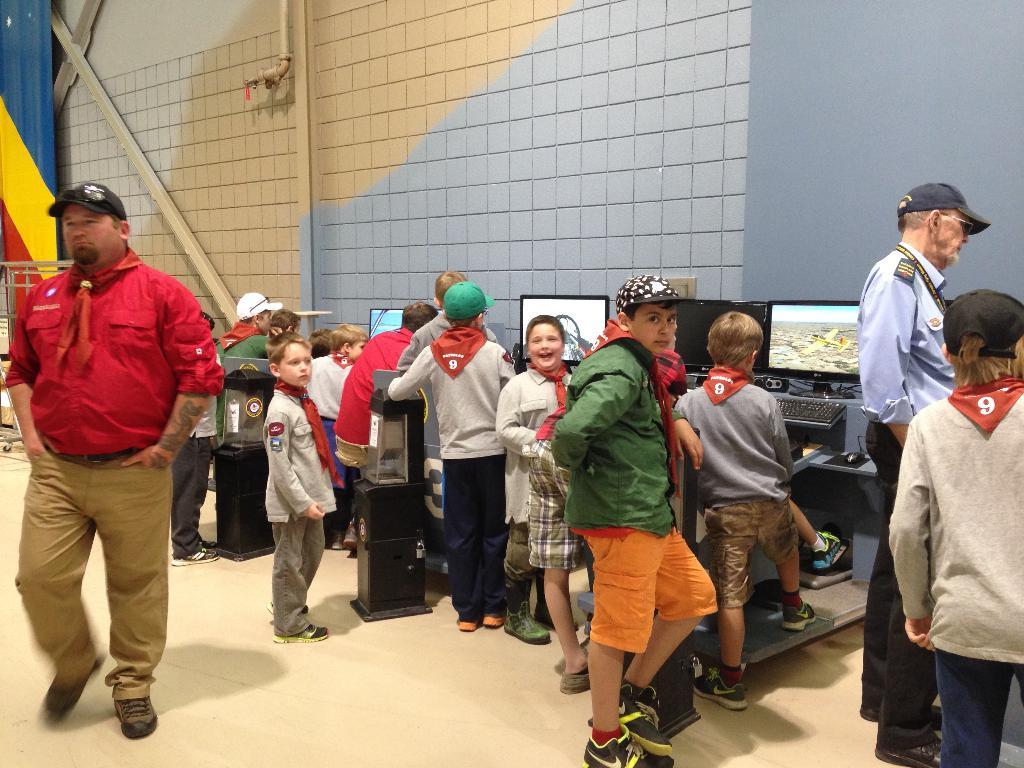How many people are in the image? There are people in the image, but the exact number is not specified. What are the people doing in the image? The people are standing in front of monitors. What can be seen in the background of the image? There is a wall in the background of the image. What type of vacation destination is visible in the image? There is no vacation destination present in the image; it features people standing in front of monitors with a wall in the background. 